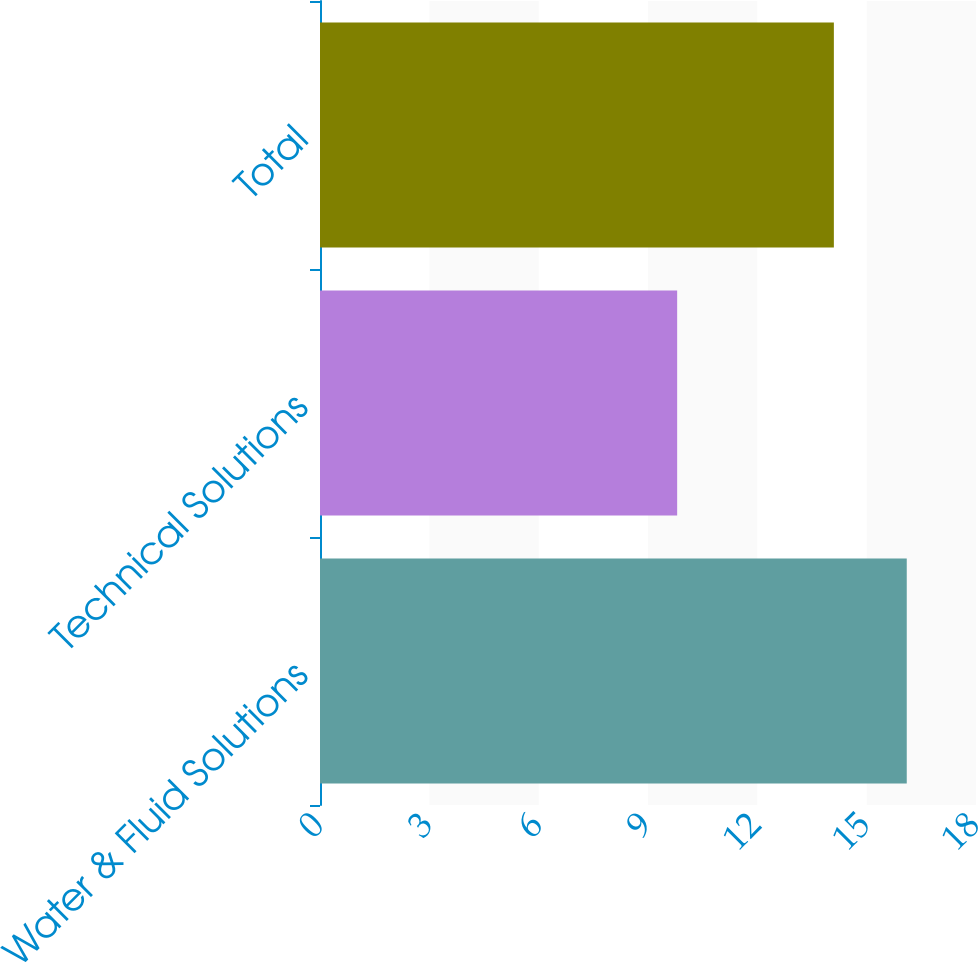Convert chart to OTSL. <chart><loc_0><loc_0><loc_500><loc_500><bar_chart><fcel>Water & Fluid Solutions<fcel>Technical Solutions<fcel>Total<nl><fcel>16.1<fcel>9.8<fcel>14.1<nl></chart> 